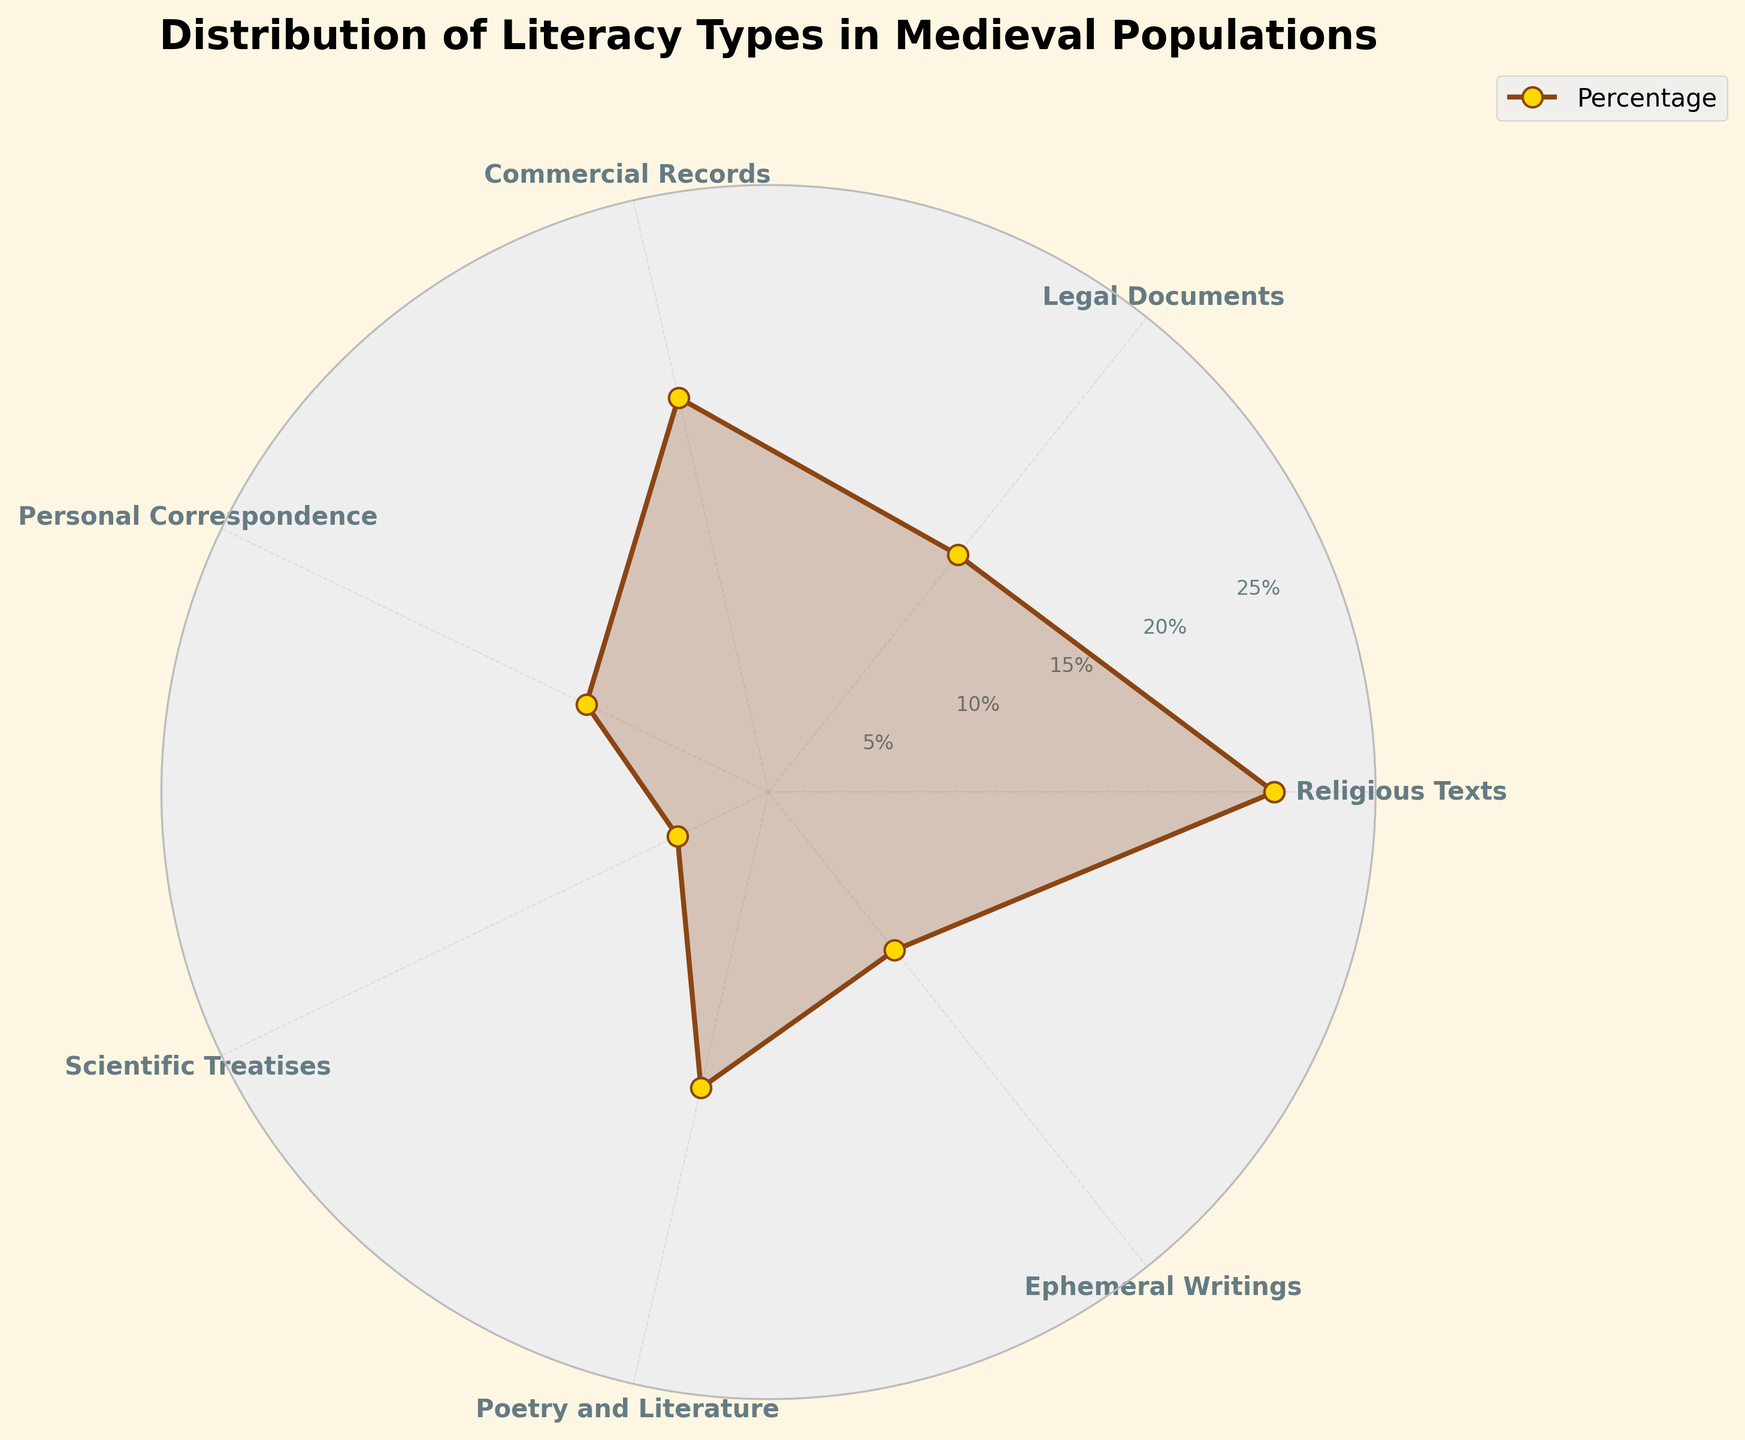What is the title of the figure? The title is usually placed at the top of the figure. Here, it's written in bold and can be read directly.
Answer: Distribution of Literacy Types in Medieval Populations Which literacy type has the highest percentage? By checking the length of the radial spokes, the longest spoke represents 'Religious Texts'.
Answer: Religious Texts How many different literacy types are represented in the chart? By counting the labels around the chart, you can see there are 7 different literacy types.
Answer: 7 What percentage of the population could read Poetry and Literature? Locate 'Poetry and Literature' in the chart and refer to its corresponding radial length, which is labeled 15%.
Answer: 15% Which literacy type has the smallest percentage? Identify the shortest radial spoke, which corresponds to 'Scientific Treatises' at 5%.
Answer: Scientific Treatises What is the combined percentage of Commercial Records and Personal Correspondence? Sum up the percentages of 'Commercial Records' (20%) and 'Personal Correspondence' (10%). 20% + 10% = 30%
Answer: 30% Is the percentage of Ephemeral Writings greater than, less than, or equal to that of Legal Documents? Compare the two radial lengths; 'Legal Documents' is 15%, whereas 'Ephemeral Writings' is 10%.
Answer: Less than What is the difference in percentages between Religious Texts and Legal Documents? Subtract the percentage of 'Legal Documents' (15%) from 'Religious Texts' (25%). 25% - 15% = 10%
Answer: 10% How does the visual representation differentiate between the radial grid lines and the literacy types? The radial grid lines are subtle and dashed, while the literacy types are bold lines and markers in brown with gold fill. This distinction helps in clearly differentiating between the grid and data.
Answer: Radial grid lines are dashed, literacy types are bold lines 